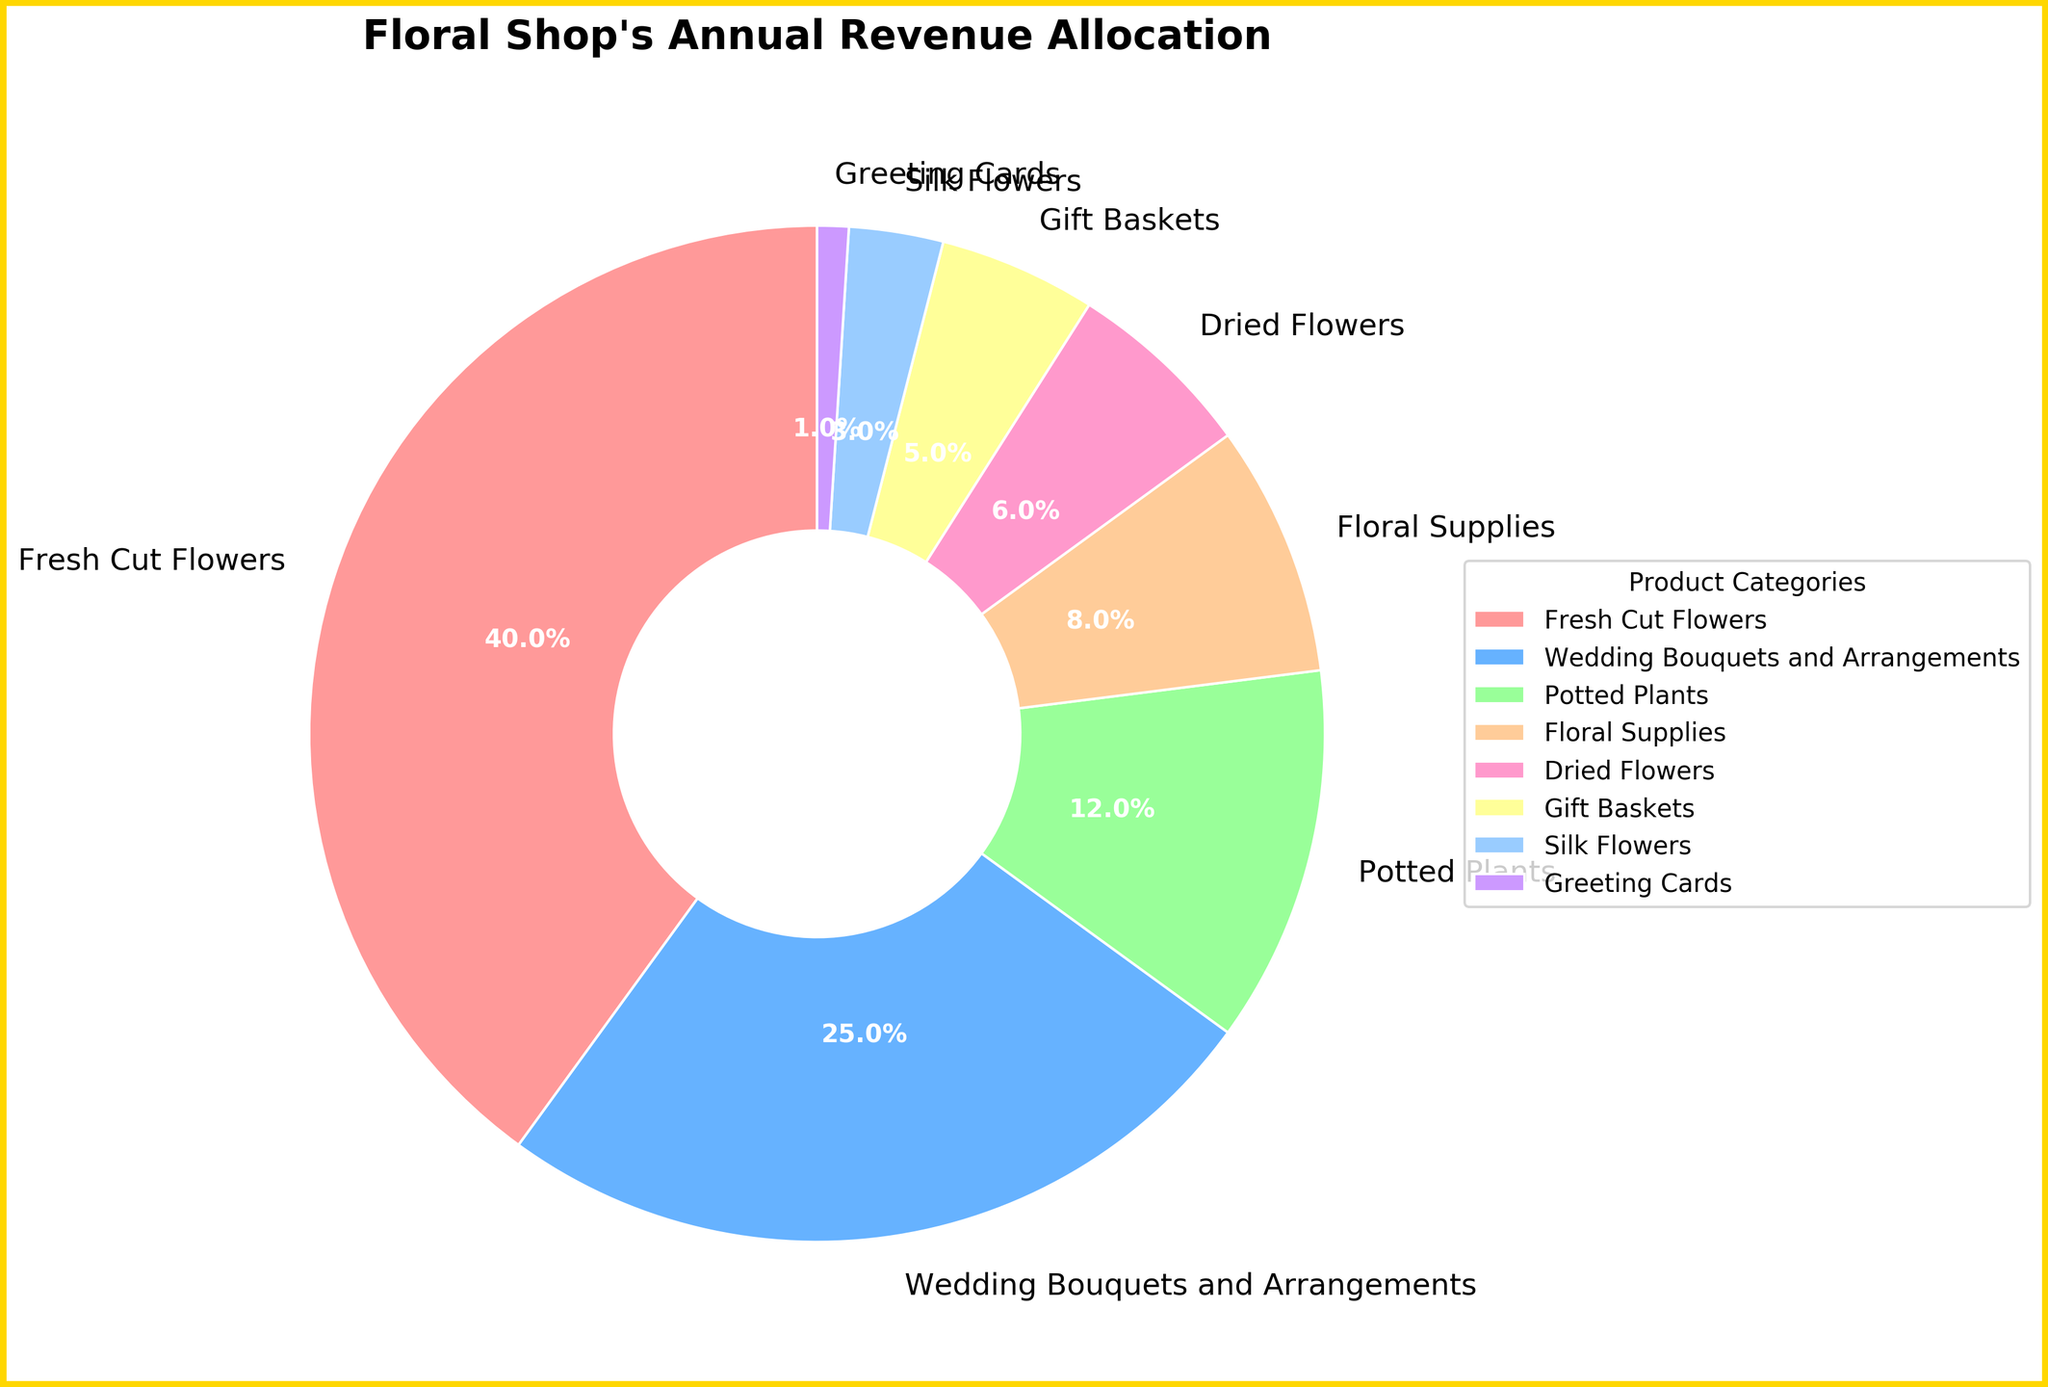Which product category generates the most revenue for the floral shop? By observing the pie chart, the product category with the largest slice represents the highest revenue. The "Fresh Cut Flowers" category occupies the largest area in the chart.
Answer: Fresh Cut Flowers How much more revenue do fresh cut flowers generate compared to greeting cards? The pie chart shows percentages for each category. Fresh Cut Flowers contribute 40%, while Greeting Cards contribute 1%. The difference is 40% - 1% = 39%.
Answer: 39% Which two categories together account for half of the floral shop's annual revenue? The pie chart shows that Fresh Cut Flowers (40%) and Wedding Bouquets and Arrangements (25%) together total 40% + 25% = 65%. To find two categories that total around 50%, Fresh Cut Flowers (40%) and Wedding Bouquets (25%) fit the requirement, slightly exceeding half the revenue.
Answer: Fresh Cut Flowers and Wedding Bouquets What is the combined contribution of potted plants, floral supplies, and dried flowers? The pie chart shows their percentages as 12%, 8%, and 6% respectively. Adding them up: 12% + 8% + 6% = 26%.
Answer: 26% Which category has a similar revenue contribution to silk flowers and greeting cards combined? Silk Flowers contribute 3% and Greeting Cards 1%, totaling 3% + 1% = 4%. The next closest category in percentage is Gift Baskets with 5%.
Answer: Gift Baskets Is the revenue from wedding bouquets and arrangements greater or less than the combination of dried flowers, gift baskets, and silk flowers? Wedding Bouquets and Arrangements contribute 25%. Dried Flowers, Gift Baskets, and Silk Flowers add up to 6% + 5% + 3% = 14%. Since 25% is greater than 14%, the revenue from Wedding Bouquets and Arrangements is greater.
Answer: Greater If the store decided to focus on the top three revenue categories, what percentage of the total revenue would that focus cover? The three largest categories are Fresh Cut Flowers (40%), Wedding Bouquets and Arrangements (25%), and Potted Plants (12%). Adding these percentages: 40% + 25% + 12% = 77%.
Answer: 77% Which product category has the smallest contribution to the floral shop's annual revenue? The pie chart shows the smallest slice is labeled as Greeting Cards, with 1% contribution.
Answer: Greeting Cards 